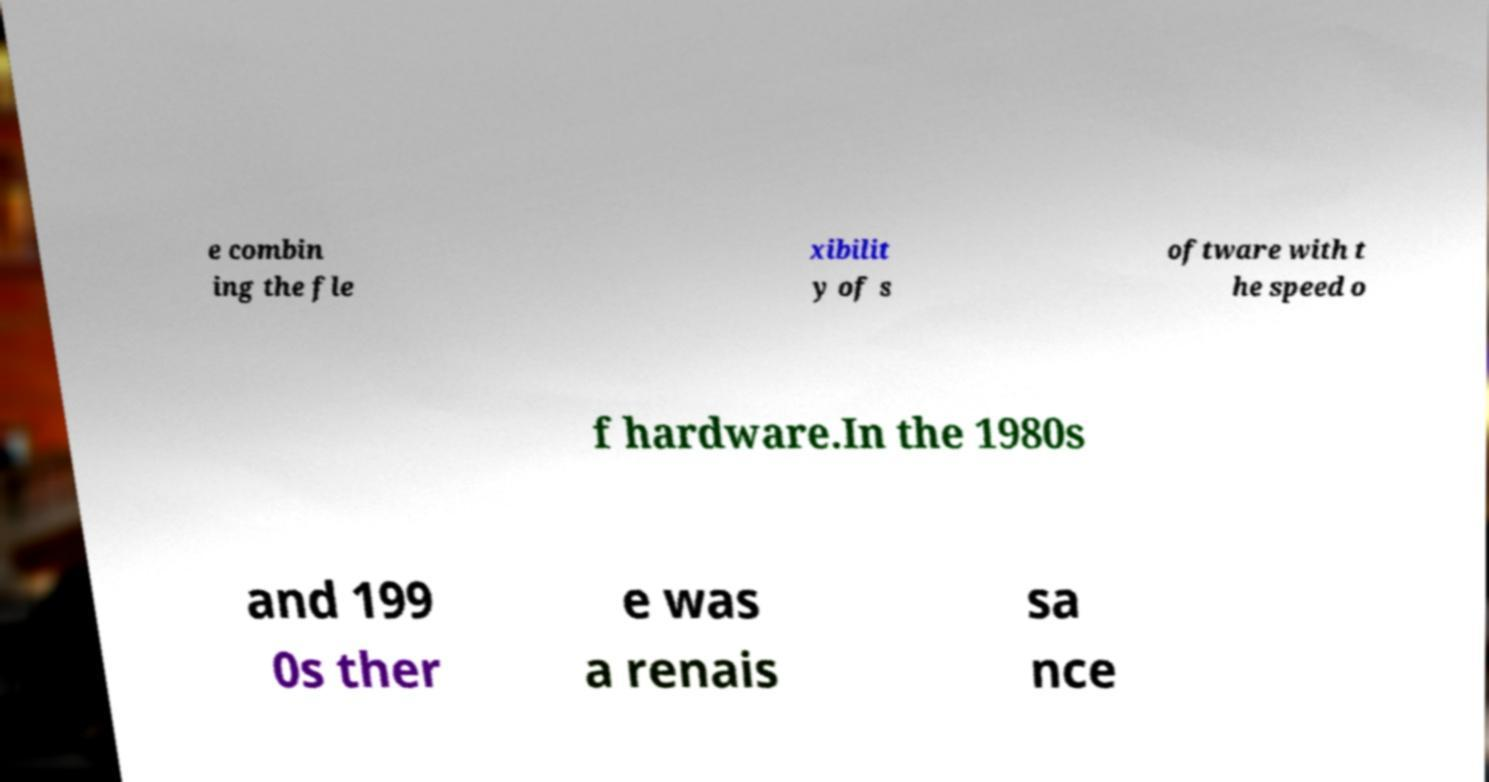Could you assist in decoding the text presented in this image and type it out clearly? e combin ing the fle xibilit y of s oftware with t he speed o f hardware.In the 1980s and 199 0s ther e was a renais sa nce 